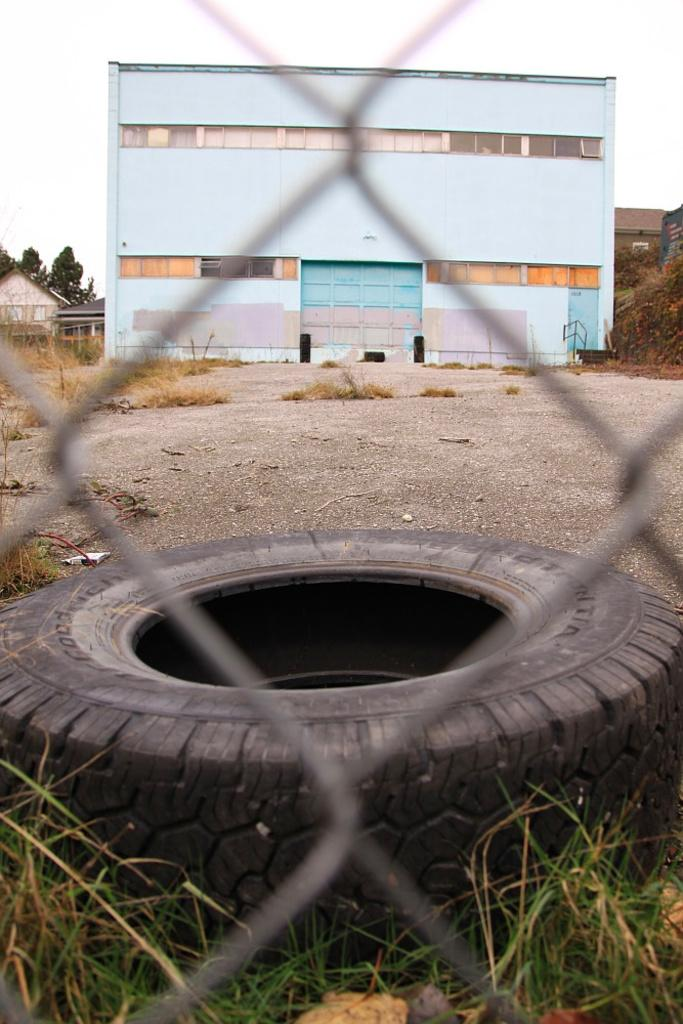What object can be seen in the image that is typically used for vehicles? There is a tyre in the image that is typically used for vehicles. What type of vegetation is present in the image? There is grass in the image. What type of structure can be seen in the image? There is a mesh in the image. What can be seen in the background of the image? Buildings, houses, trees, walls, a road, and the sky are visible in the background of the image. Is there a tent set up on the ground in the image? There is no tent present in the image. What organization is responsible for the structures in the image? The image does not provide information about any organization responsible for the structures. 